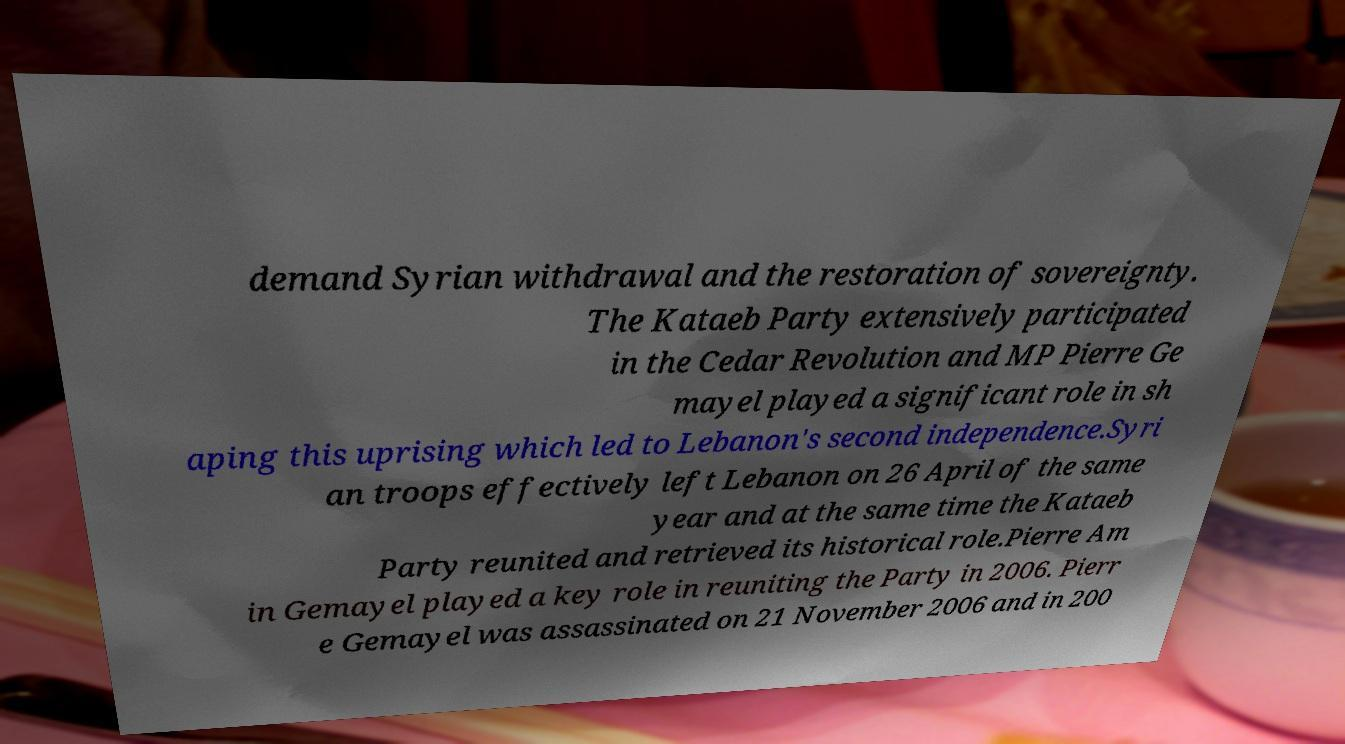Can you accurately transcribe the text from the provided image for me? demand Syrian withdrawal and the restoration of sovereignty. The Kataeb Party extensively participated in the Cedar Revolution and MP Pierre Ge mayel played a significant role in sh aping this uprising which led to Lebanon's second independence.Syri an troops effectively left Lebanon on 26 April of the same year and at the same time the Kataeb Party reunited and retrieved its historical role.Pierre Am in Gemayel played a key role in reuniting the Party in 2006. Pierr e Gemayel was assassinated on 21 November 2006 and in 200 